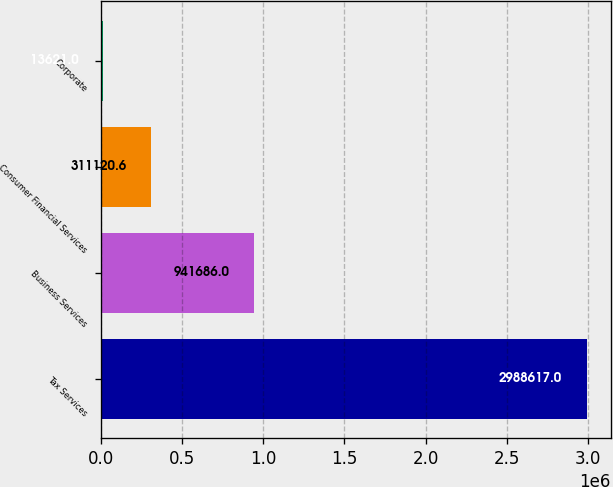<chart> <loc_0><loc_0><loc_500><loc_500><bar_chart><fcel>Tax Services<fcel>Business Services<fcel>Consumer Financial Services<fcel>Corporate<nl><fcel>2.98862e+06<fcel>941686<fcel>311121<fcel>13621<nl></chart> 